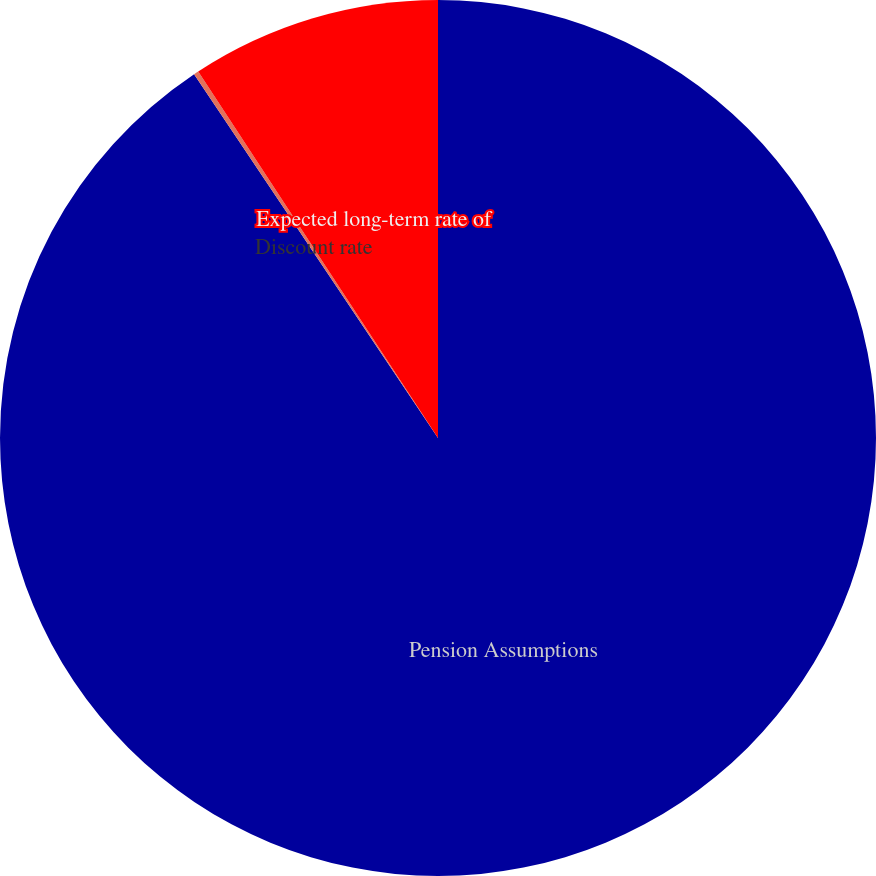Convert chart. <chart><loc_0><loc_0><loc_500><loc_500><pie_chart><fcel>Pension Assumptions<fcel>Discount rate<fcel>Expected long-term rate of<nl><fcel>90.6%<fcel>0.18%<fcel>9.22%<nl></chart> 